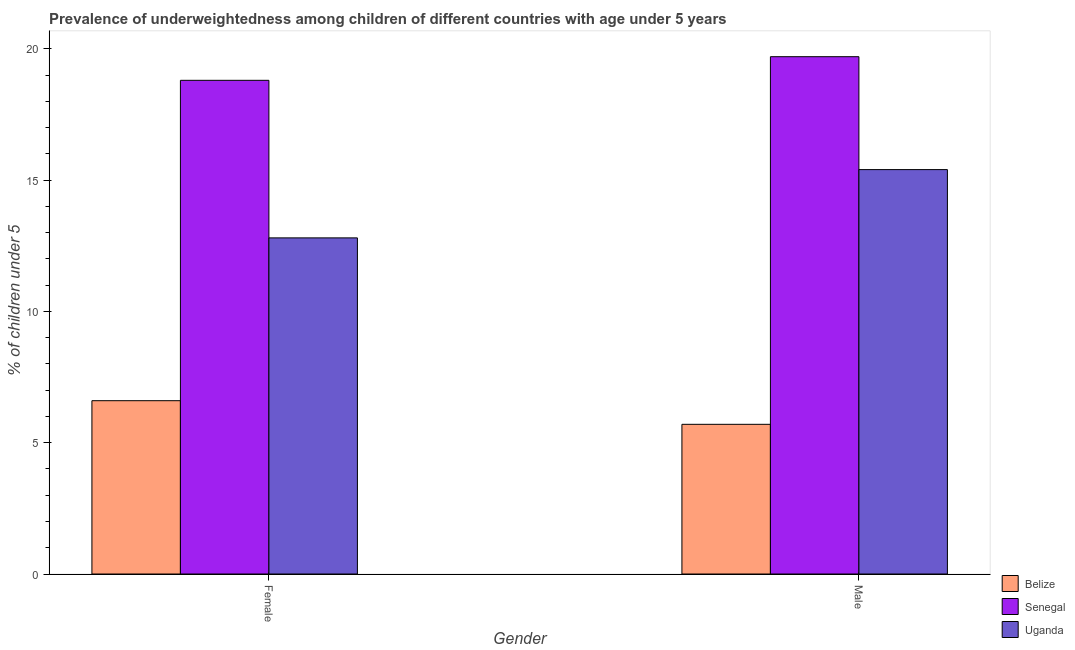Are the number of bars per tick equal to the number of legend labels?
Your answer should be compact. Yes. Are the number of bars on each tick of the X-axis equal?
Offer a terse response. Yes. How many bars are there on the 2nd tick from the right?
Provide a short and direct response. 3. What is the percentage of underweighted female children in Belize?
Provide a succinct answer. 6.6. Across all countries, what is the maximum percentage of underweighted male children?
Make the answer very short. 19.7. Across all countries, what is the minimum percentage of underweighted female children?
Keep it short and to the point. 6.6. In which country was the percentage of underweighted male children maximum?
Your answer should be very brief. Senegal. In which country was the percentage of underweighted male children minimum?
Provide a succinct answer. Belize. What is the total percentage of underweighted male children in the graph?
Your response must be concise. 40.8. What is the difference between the percentage of underweighted female children in Belize and that in Uganda?
Offer a terse response. -6.2. What is the difference between the percentage of underweighted female children in Senegal and the percentage of underweighted male children in Belize?
Your answer should be very brief. 13.1. What is the average percentage of underweighted female children per country?
Offer a very short reply. 12.73. What is the difference between the percentage of underweighted male children and percentage of underweighted female children in Senegal?
Your response must be concise. 0.9. What is the ratio of the percentage of underweighted female children in Uganda to that in Senegal?
Your answer should be compact. 0.68. In how many countries, is the percentage of underweighted male children greater than the average percentage of underweighted male children taken over all countries?
Your answer should be very brief. 2. What does the 2nd bar from the left in Female represents?
Make the answer very short. Senegal. What does the 1st bar from the right in Male represents?
Provide a short and direct response. Uganda. How many bars are there?
Provide a short and direct response. 6. Are all the bars in the graph horizontal?
Give a very brief answer. No. What is the difference between two consecutive major ticks on the Y-axis?
Offer a terse response. 5. Are the values on the major ticks of Y-axis written in scientific E-notation?
Your answer should be compact. No. Does the graph contain any zero values?
Your answer should be very brief. No. Does the graph contain grids?
Ensure brevity in your answer.  No. Where does the legend appear in the graph?
Give a very brief answer. Bottom right. How are the legend labels stacked?
Offer a terse response. Vertical. What is the title of the graph?
Your answer should be compact. Prevalence of underweightedness among children of different countries with age under 5 years. What is the label or title of the X-axis?
Provide a succinct answer. Gender. What is the label or title of the Y-axis?
Your answer should be very brief.  % of children under 5. What is the  % of children under 5 in Belize in Female?
Your answer should be very brief. 6.6. What is the  % of children under 5 in Senegal in Female?
Offer a terse response. 18.8. What is the  % of children under 5 in Uganda in Female?
Your answer should be compact. 12.8. What is the  % of children under 5 of Belize in Male?
Your response must be concise. 5.7. What is the  % of children under 5 in Senegal in Male?
Provide a short and direct response. 19.7. What is the  % of children under 5 of Uganda in Male?
Provide a short and direct response. 15.4. Across all Gender, what is the maximum  % of children under 5 of Belize?
Offer a terse response. 6.6. Across all Gender, what is the maximum  % of children under 5 of Senegal?
Keep it short and to the point. 19.7. Across all Gender, what is the maximum  % of children under 5 in Uganda?
Your response must be concise. 15.4. Across all Gender, what is the minimum  % of children under 5 in Belize?
Make the answer very short. 5.7. Across all Gender, what is the minimum  % of children under 5 of Senegal?
Provide a short and direct response. 18.8. Across all Gender, what is the minimum  % of children under 5 of Uganda?
Provide a succinct answer. 12.8. What is the total  % of children under 5 of Senegal in the graph?
Offer a very short reply. 38.5. What is the total  % of children under 5 of Uganda in the graph?
Provide a succinct answer. 28.2. What is the difference between the  % of children under 5 in Senegal in Female and that in Male?
Keep it short and to the point. -0.9. What is the difference between the  % of children under 5 of Uganda in Female and that in Male?
Provide a succinct answer. -2.6. What is the difference between the  % of children under 5 in Belize in Female and the  % of children under 5 in Senegal in Male?
Your answer should be very brief. -13.1. What is the difference between the  % of children under 5 in Belize in Female and the  % of children under 5 in Uganda in Male?
Provide a succinct answer. -8.8. What is the average  % of children under 5 in Belize per Gender?
Your response must be concise. 6.15. What is the average  % of children under 5 of Senegal per Gender?
Your answer should be compact. 19.25. What is the difference between the  % of children under 5 of Belize and  % of children under 5 of Senegal in Female?
Make the answer very short. -12.2. What is the difference between the  % of children under 5 of Belize and  % of children under 5 of Uganda in Female?
Your response must be concise. -6.2. What is the difference between the  % of children under 5 of Senegal and  % of children under 5 of Uganda in Female?
Give a very brief answer. 6. What is the difference between the  % of children under 5 of Belize and  % of children under 5 of Uganda in Male?
Your response must be concise. -9.7. What is the difference between the  % of children under 5 in Senegal and  % of children under 5 in Uganda in Male?
Ensure brevity in your answer.  4.3. What is the ratio of the  % of children under 5 in Belize in Female to that in Male?
Provide a short and direct response. 1.16. What is the ratio of the  % of children under 5 in Senegal in Female to that in Male?
Provide a succinct answer. 0.95. What is the ratio of the  % of children under 5 in Uganda in Female to that in Male?
Make the answer very short. 0.83. What is the difference between the highest and the lowest  % of children under 5 of Senegal?
Your response must be concise. 0.9. What is the difference between the highest and the lowest  % of children under 5 in Uganda?
Your answer should be compact. 2.6. 